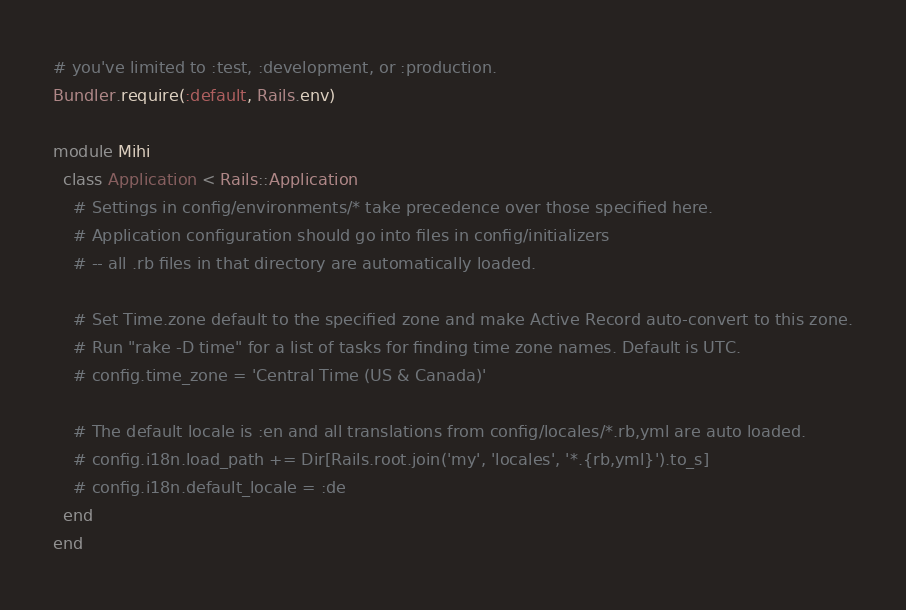Convert code to text. <code><loc_0><loc_0><loc_500><loc_500><_Ruby_># you've limited to :test, :development, or :production.
Bundler.require(:default, Rails.env)

module Mihi
  class Application < Rails::Application
    # Settings in config/environments/* take precedence over those specified here.
    # Application configuration should go into files in config/initializers
    # -- all .rb files in that directory are automatically loaded.

    # Set Time.zone default to the specified zone and make Active Record auto-convert to this zone.
    # Run "rake -D time" for a list of tasks for finding time zone names. Default is UTC.
    # config.time_zone = 'Central Time (US & Canada)'

    # The default locale is :en and all translations from config/locales/*.rb,yml are auto loaded.
    # config.i18n.load_path += Dir[Rails.root.join('my', 'locales', '*.{rb,yml}').to_s]
    # config.i18n.default_locale = :de
  end
end
</code> 